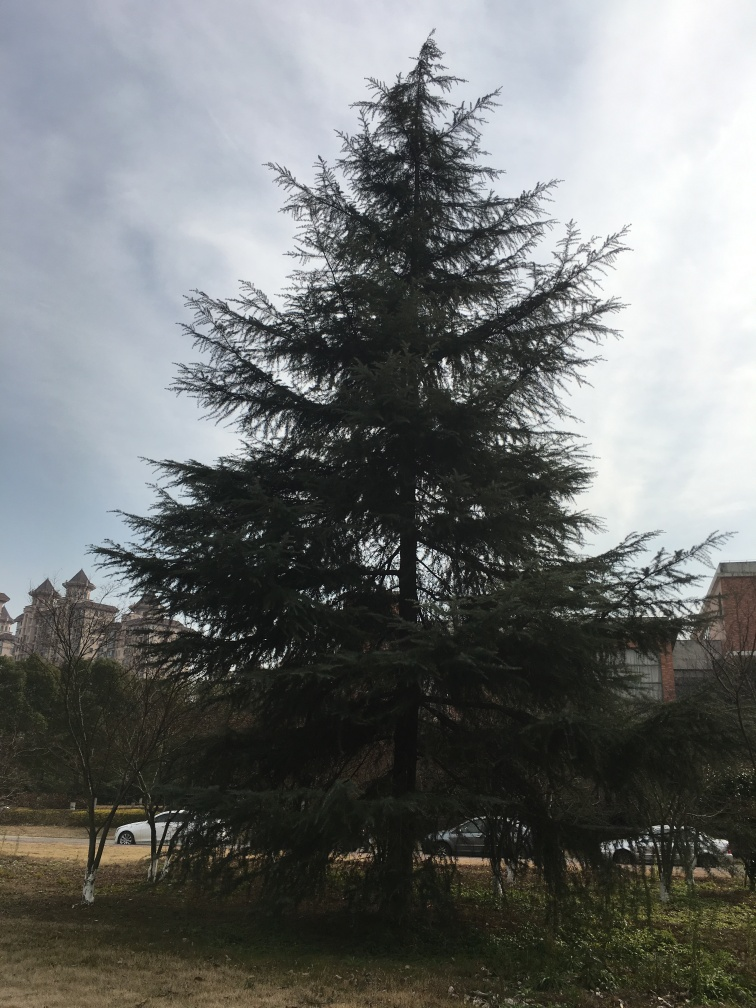What features rich texture details in the image? A. subject B. ground C. nothing D. sky The subject, which is the tree in the image, exhibits rich texture details with its complex network of branches and leaves. The intricate patterns formed by the foliage and the way the light plays on them creates a lively texture that is captivating to observe. 